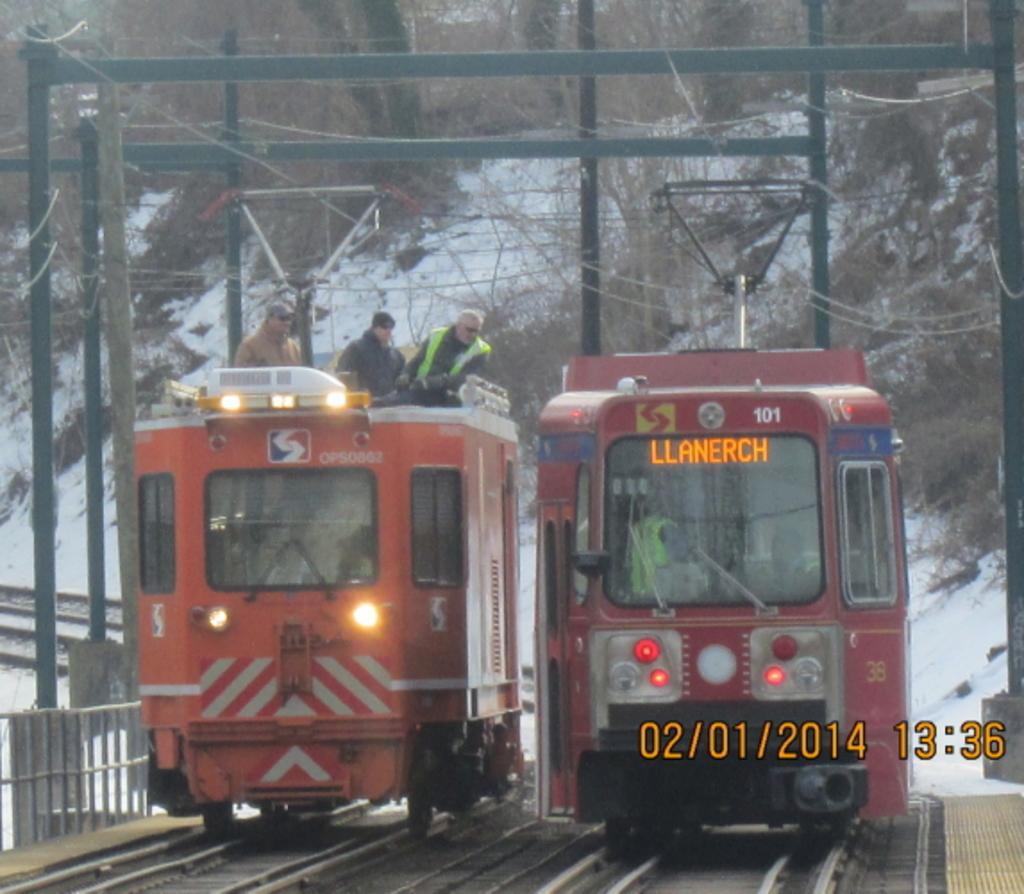What are the people in the image doing? The people are in locomotives on the track. What can be seen alongside the track in the image? There is a fence in the image. What else can be seen in the image besides the fence? There are poles and wires visible in the image. What can be seen in the background of the image? There are trees and snow visible in the background. How many cattle can be seen grazing in the image? There are no cattle present in the image. What type of blade is being used by the people in the locomotives? There is no blade visible in the image, and the people in the locomotives are not using any blades. 